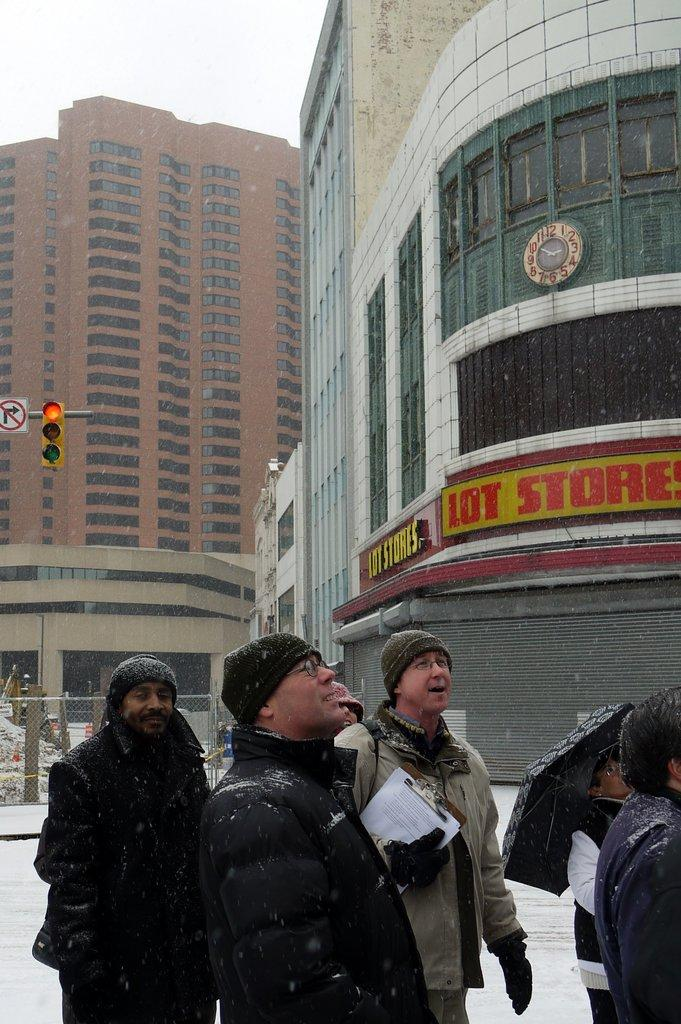What are the people in the image doing? There is a group of people standing on the ground in the image. What can be seen in the background of the image? The sky is visible in the background of the image. What type of structures are present in the image? There are buildings with windows in the image. What is used to separate or enclose areas in the image? There is a fence in the image. What device is used to control traffic in the image? A traffic signal light is present in the image. What is used for displaying information or advertisements in the image? There is a signboard in the image. What type of lace is used to decorate the buildings in the image? There is no mention of lace in the image; the buildings have windows, but no specific decorations are described. How do the people in the image support each other while standing on the ground? The image does not show the people supporting each other; they are simply standing on the ground. 